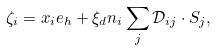<formula> <loc_0><loc_0><loc_500><loc_500>\zeta _ { i } = x _ { i } e _ { h } + \xi _ { d } n _ { i } \sum _ { j } \mathcal { D } _ { i j } \cdot S _ { j } ,</formula> 